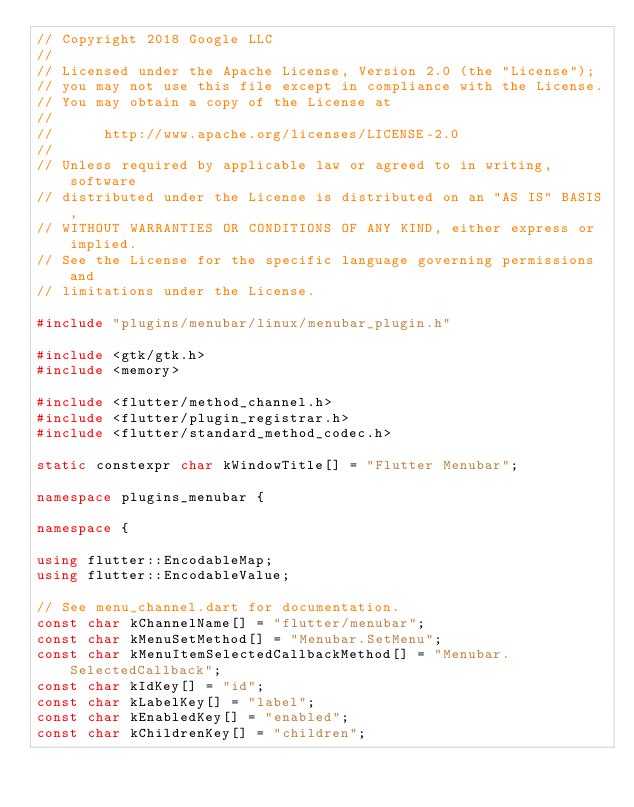<code> <loc_0><loc_0><loc_500><loc_500><_C++_>// Copyright 2018 Google LLC
//
// Licensed under the Apache License, Version 2.0 (the "License");
// you may not use this file except in compliance with the License.
// You may obtain a copy of the License at
//
//      http://www.apache.org/licenses/LICENSE-2.0
//
// Unless required by applicable law or agreed to in writing, software
// distributed under the License is distributed on an "AS IS" BASIS,
// WITHOUT WARRANTIES OR CONDITIONS OF ANY KIND, either express or implied.
// See the License for the specific language governing permissions and
// limitations under the License.

#include "plugins/menubar/linux/menubar_plugin.h"

#include <gtk/gtk.h>
#include <memory>

#include <flutter/method_channel.h>
#include <flutter/plugin_registrar.h>
#include <flutter/standard_method_codec.h>

static constexpr char kWindowTitle[] = "Flutter Menubar";

namespace plugins_menubar {

namespace {

using flutter::EncodableMap;
using flutter::EncodableValue;

// See menu_channel.dart for documentation.
const char kChannelName[] = "flutter/menubar";
const char kMenuSetMethod[] = "Menubar.SetMenu";
const char kMenuItemSelectedCallbackMethod[] = "Menubar.SelectedCallback";
const char kIdKey[] = "id";
const char kLabelKey[] = "label";
const char kEnabledKey[] = "enabled";
const char kChildrenKey[] = "children";</code> 